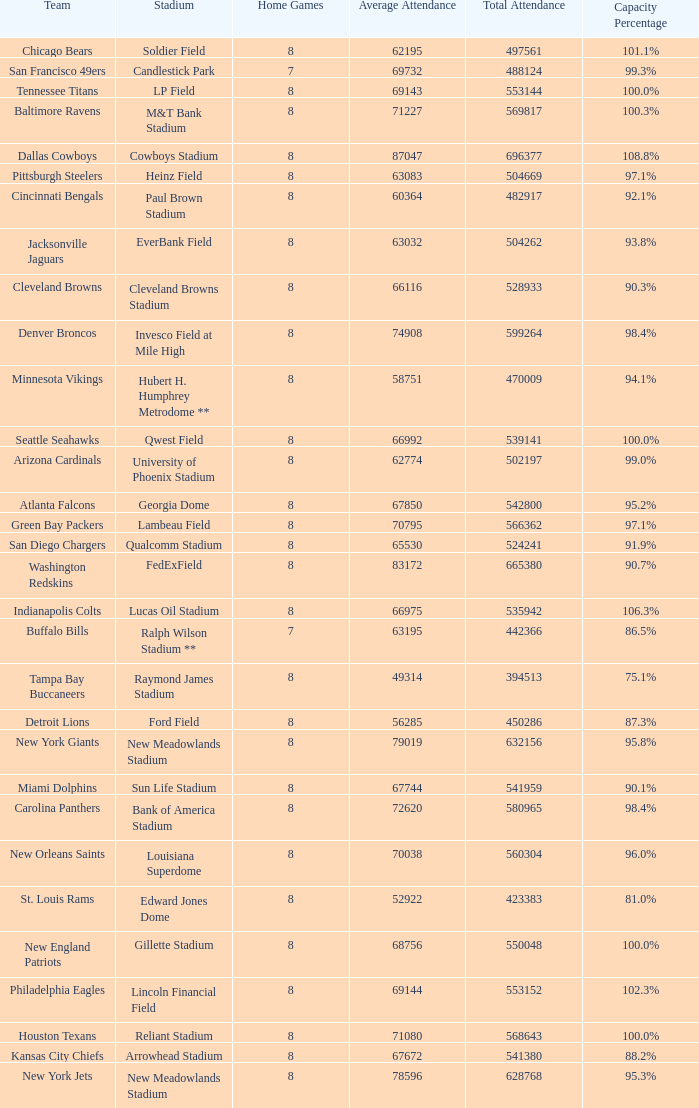What was the total attendance of the New York Giants? 632156.0. 